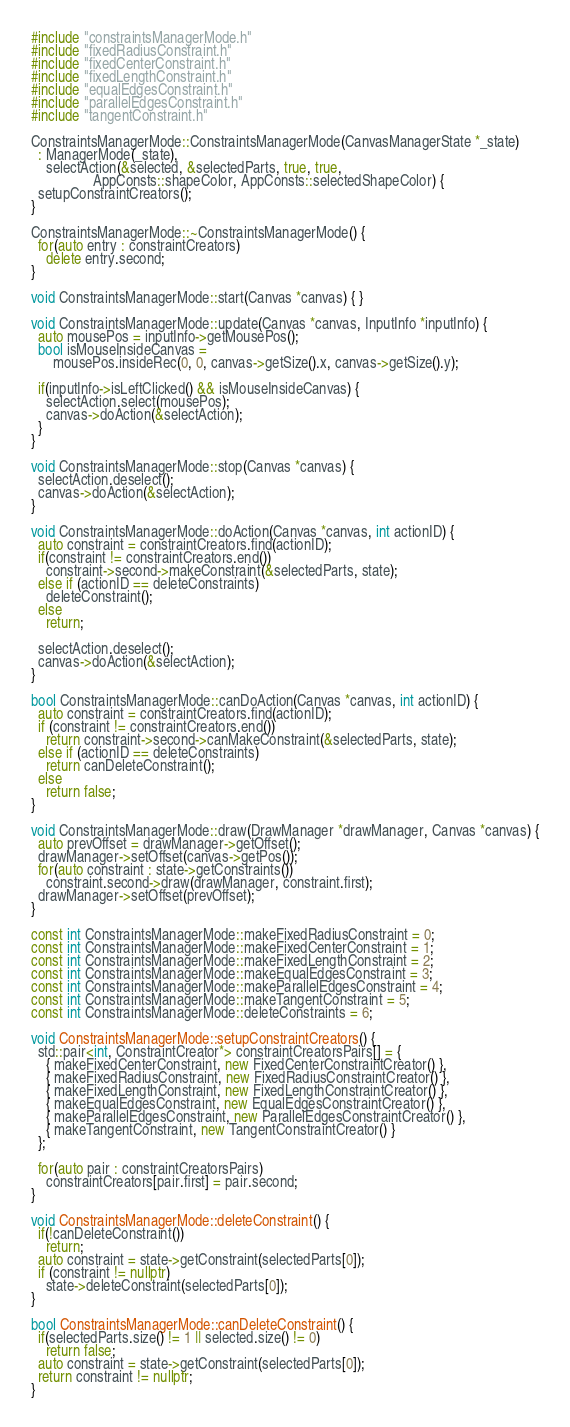Convert code to text. <code><loc_0><loc_0><loc_500><loc_500><_C++_>#include "constraintsManagerMode.h"
#include "fixedRadiusConstraint.h"
#include "fixedCenterConstraint.h"
#include "fixedLengthConstraint.h"
#include "equalEdgesConstraint.h"
#include "parallelEdgesConstraint.h"
#include "tangentConstraint.h"

ConstraintsManagerMode::ConstraintsManagerMode(CanvasManagerState *_state)
  : ManagerMode(_state),
    selectAction(&selected, &selectedParts, true, true,
                 AppConsts::shapeColor, AppConsts::selectedShapeColor) {
  setupConstraintCreators();
}

ConstraintsManagerMode::~ConstraintsManagerMode() {
  for(auto entry : constraintCreators)
    delete entry.second;
}

void ConstraintsManagerMode::start(Canvas *canvas) { }

void ConstraintsManagerMode::update(Canvas *canvas, InputInfo *inputInfo) {
  auto mousePos = inputInfo->getMousePos();
  bool isMouseInsideCanvas =
      mousePos.insideRec(0, 0, canvas->getSize().x, canvas->getSize().y);

  if(inputInfo->isLeftClicked() && isMouseInsideCanvas) {
    selectAction.select(mousePos);
    canvas->doAction(&selectAction);
  }
}

void ConstraintsManagerMode::stop(Canvas *canvas) {
  selectAction.deselect();
  canvas->doAction(&selectAction);
}

void ConstraintsManagerMode::doAction(Canvas *canvas, int actionID) {
  auto constraint = constraintCreators.find(actionID);
  if(constraint != constraintCreators.end())
    constraint->second->makeConstraint(&selectedParts, state);
  else if (actionID == deleteConstraints)
    deleteConstraint();
  else
    return;

  selectAction.deselect();
  canvas->doAction(&selectAction);
}

bool ConstraintsManagerMode::canDoAction(Canvas *canvas, int actionID) {
  auto constraint = constraintCreators.find(actionID);
  if (constraint != constraintCreators.end())
    return constraint->second->canMakeConstraint(&selectedParts, state);
  else if (actionID == deleteConstraints)
    return canDeleteConstraint();
  else
    return false;
}

void ConstraintsManagerMode::draw(DrawManager *drawManager, Canvas *canvas) {
  auto prevOffset = drawManager->getOffset();
  drawManager->setOffset(canvas->getPos());
  for(auto constraint : state->getConstraints())
    constraint.second->draw(drawManager, constraint.first);
  drawManager->setOffset(prevOffset);
}

const int ConstraintsManagerMode::makeFixedRadiusConstraint = 0;
const int ConstraintsManagerMode::makeFixedCenterConstraint = 1;
const int ConstraintsManagerMode::makeFixedLengthConstraint = 2;
const int ConstraintsManagerMode::makeEqualEdgesConstraint = 3;
const int ConstraintsManagerMode::makeParallelEdgesConstraint = 4;
const int ConstraintsManagerMode::makeTangentConstraint = 5;
const int ConstraintsManagerMode::deleteConstraints = 6;

void ConstraintsManagerMode::setupConstraintCreators() {
  std::pair<int, ConstraintCreator*> constraintCreatorsPairs[] = {
    { makeFixedCenterConstraint, new FixedCenterConstraintCreator() },
    { makeFixedRadiusConstraint, new FixedRadiusConstraintCreator() },
    { makeFixedLengthConstraint, new FixedLengthConstraintCreator() },
    { makeEqualEdgesConstraint, new EqualEdgesConstraintCreator() },
    { makeParallelEdgesConstraint, new ParallelEdgesConstraintCreator() },
    { makeTangentConstraint, new TangentConstraintCreator() }
  };

  for(auto pair : constraintCreatorsPairs)
    constraintCreators[pair.first] = pair.second;
}

void ConstraintsManagerMode::deleteConstraint() {
  if(!canDeleteConstraint())
    return;
  auto constraint = state->getConstraint(selectedParts[0]);
  if (constraint != nullptr)
    state->deleteConstraint(selectedParts[0]);
}

bool ConstraintsManagerMode::canDeleteConstraint() {
  if(selectedParts.size() != 1 || selected.size() != 0)
    return false;
  auto constraint = state->getConstraint(selectedParts[0]);
  return constraint != nullptr;
}
</code> 